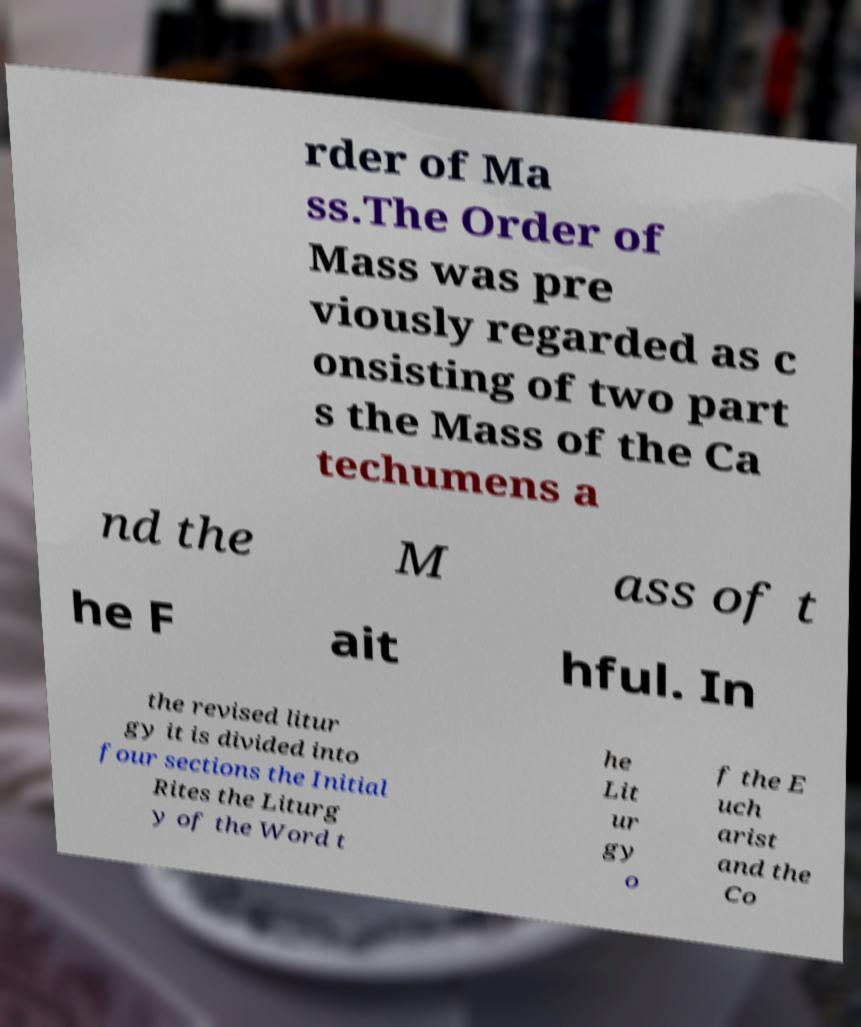Could you extract and type out the text from this image? rder of Ma ss.The Order of Mass was pre viously regarded as c onsisting of two part s the Mass of the Ca techumens a nd the M ass of t he F ait hful. In the revised litur gy it is divided into four sections the Initial Rites the Liturg y of the Word t he Lit ur gy o f the E uch arist and the Co 